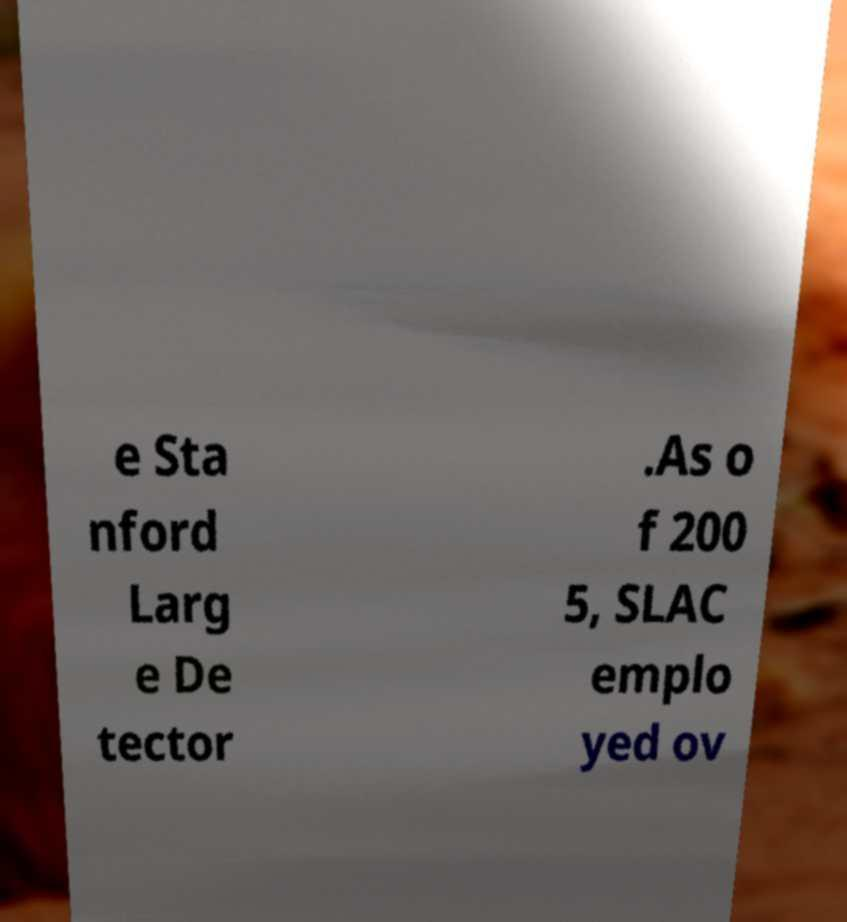What messages or text are displayed in this image? I need them in a readable, typed format. e Sta nford Larg e De tector .As o f 200 5, SLAC emplo yed ov 